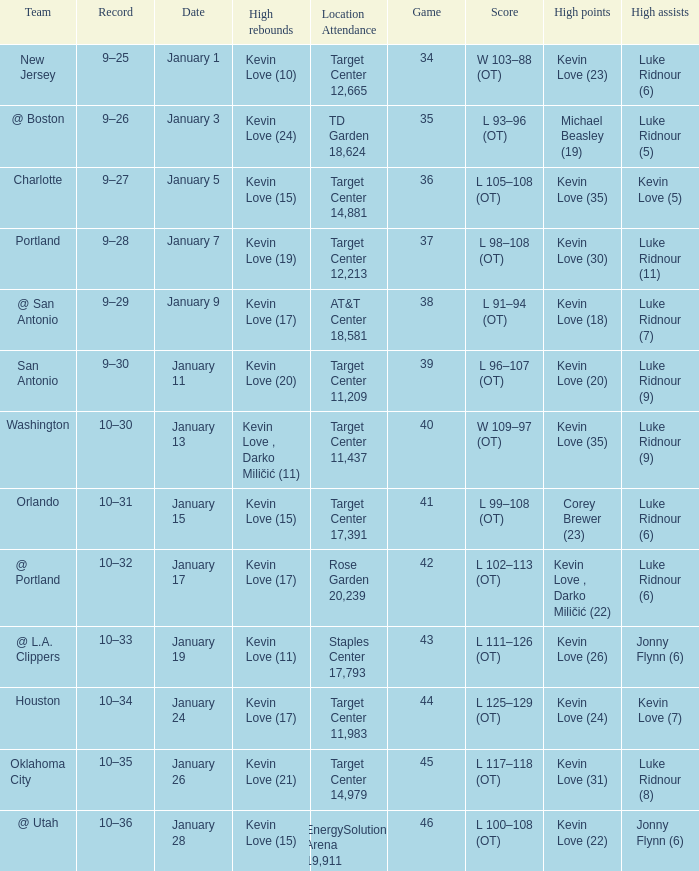Who had the high points when the team was charlotte? Kevin Love (35). 